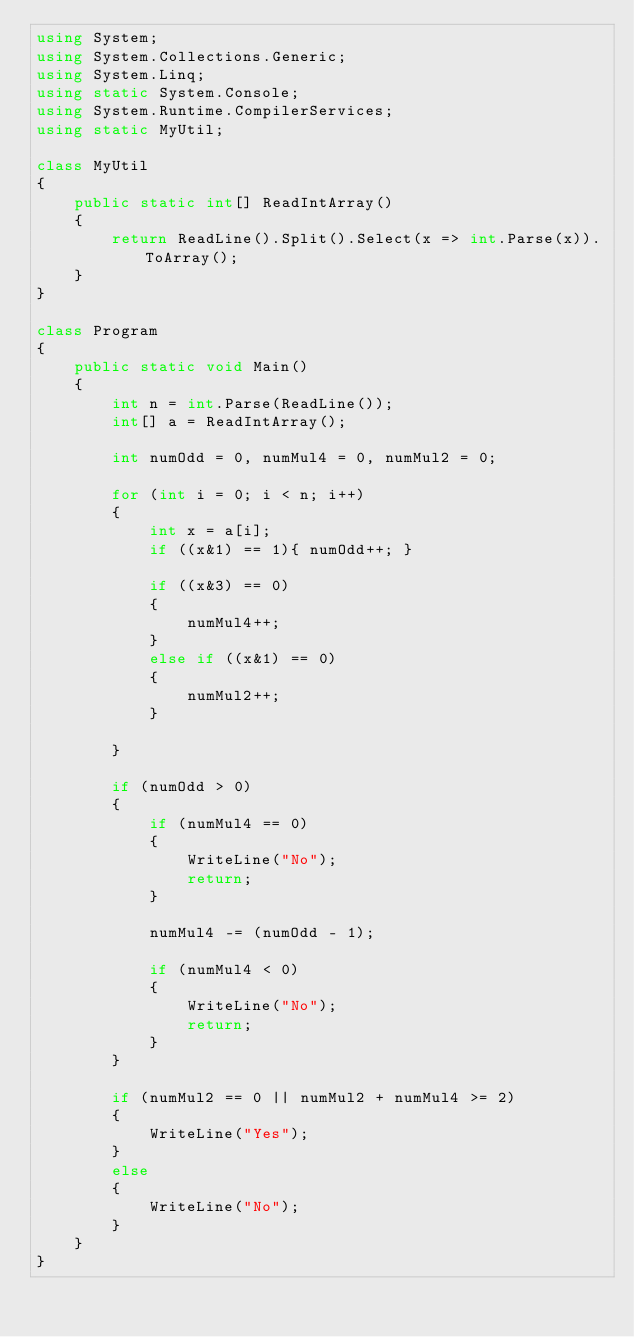<code> <loc_0><loc_0><loc_500><loc_500><_C#_>using System;
using System.Collections.Generic;
using System.Linq;
using static System.Console;
using System.Runtime.CompilerServices;
using static MyUtil;

class MyUtil
{
    public static int[] ReadIntArray()
    {
        return ReadLine().Split().Select(x => int.Parse(x)).ToArray();
    }
}

class Program
{
    public static void Main()
    {
        int n = int.Parse(ReadLine());
        int[] a = ReadIntArray();

        int numOdd = 0, numMul4 = 0, numMul2 = 0;

        for (int i = 0; i < n; i++)
        {
            int x = a[i];
            if ((x&1) == 1){ numOdd++; }

            if ((x&3) == 0)
            {
                numMul4++;
            }
            else if ((x&1) == 0)
            {
                numMul2++;
            }

        }
      
        if (numOdd > 0)
        {
            if (numMul4 == 0)
            {
                WriteLine("No");
                return;
            }

            numMul4 -= (numOdd - 1);

            if (numMul4 < 0)
            {
                WriteLine("No");
                return;
            }
        }

        if (numMul2 == 0 || numMul2 + numMul4 >= 2)
        {
            WriteLine("Yes");
        }
        else
        {
            WriteLine("No");
        }
    }
}</code> 